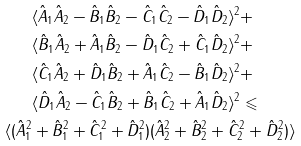<formula> <loc_0><loc_0><loc_500><loc_500>& \langle \hat { A } _ { 1 } \hat { A } _ { 2 } - \hat { B } _ { 1 } \hat { B } _ { 2 } - \hat { C } _ { 1 } \hat { C } _ { 2 } - \hat { D } _ { 1 } \hat { D } _ { 2 } \rangle ^ { 2 } + \\ & \langle \hat { B } _ { 1 } \hat { A } _ { 2 } + \hat { A } _ { 1 } \hat { B } _ { 2 } - \hat { D } _ { 1 } \hat { C } _ { 2 } + \hat { C } _ { 1 } \hat { D } _ { 2 } \rangle ^ { 2 } + \\ & \langle \hat { C } _ { 1 } \hat { A } _ { 2 } + \hat { D } _ { 1 } \hat { B } _ { 2 } + \hat { A } _ { 1 } \hat { C } _ { 2 } - \hat { B } _ { 1 } \hat { D } _ { 2 } \rangle ^ { 2 } + \\ & \langle \hat { D } _ { 1 } \hat { A } _ { 2 } - \hat { C } _ { 1 } \hat { B } _ { 2 } + \hat { B } _ { 1 } \hat { C } _ { 2 } + \hat { A } _ { 1 } \hat { D } _ { 2 } \rangle ^ { 2 } \leqslant \\ \langle ( \hat { A } ^ { 2 } _ { 1 } & + \hat { B } ^ { 2 } _ { 1 } + \hat { C } ^ { 2 } _ { 1 } + \hat { D } ^ { 2 } _ { 1 } ) ( \hat { A } ^ { 2 } _ { 2 } + \hat { B } ^ { 2 } _ { 2 } + \hat { C } ^ { 2 } _ { 2 } + \hat { D } ^ { 2 } _ { 2 } ) \rangle</formula> 